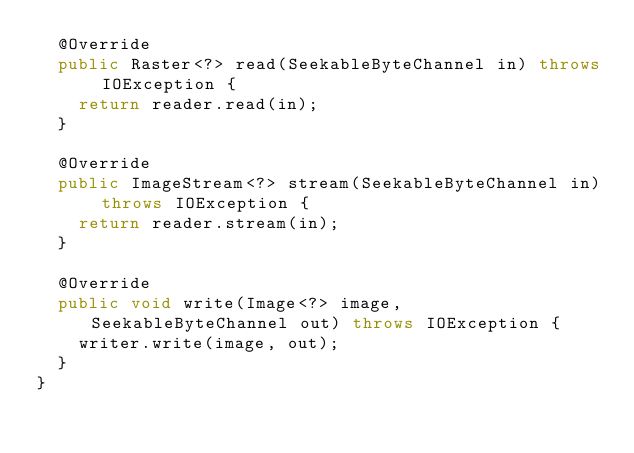Convert code to text. <code><loc_0><loc_0><loc_500><loc_500><_Java_>  @Override
  public Raster<?> read(SeekableByteChannel in) throws IOException {
    return reader.read(in);
  }

  @Override
  public ImageStream<?> stream(SeekableByteChannel in) throws IOException {
    return reader.stream(in);
  }

  @Override
  public void write(Image<?> image, SeekableByteChannel out) throws IOException {
    writer.write(image, out);
  }
}
</code> 